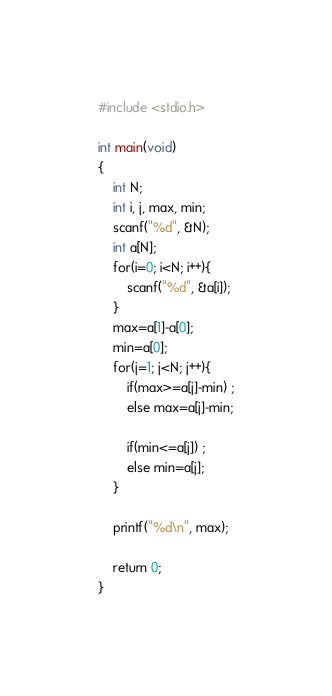Convert code to text. <code><loc_0><loc_0><loc_500><loc_500><_C_>#include <stdio.h>

int main(void)
{
	int N;
	int i, j, max, min;
	scanf("%d", &N);
	int a[N];
	for(i=0; i<N; i++){
		scanf("%d", &a[i]);
	}
	max=a[1]-a[0];
	min=a[0];
	for(j=1; j<N; j++){
		if(max>=a[j]-min) ;
		else max=a[j]-min;
		
		if(min<=a[j]) ;
		else min=a[j];
	}
	
	printf("%d\n", max);
	
	return 0;
}
</code> 